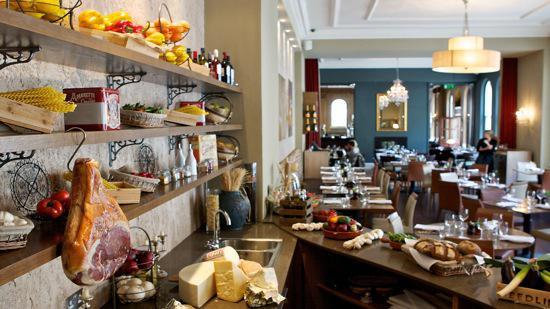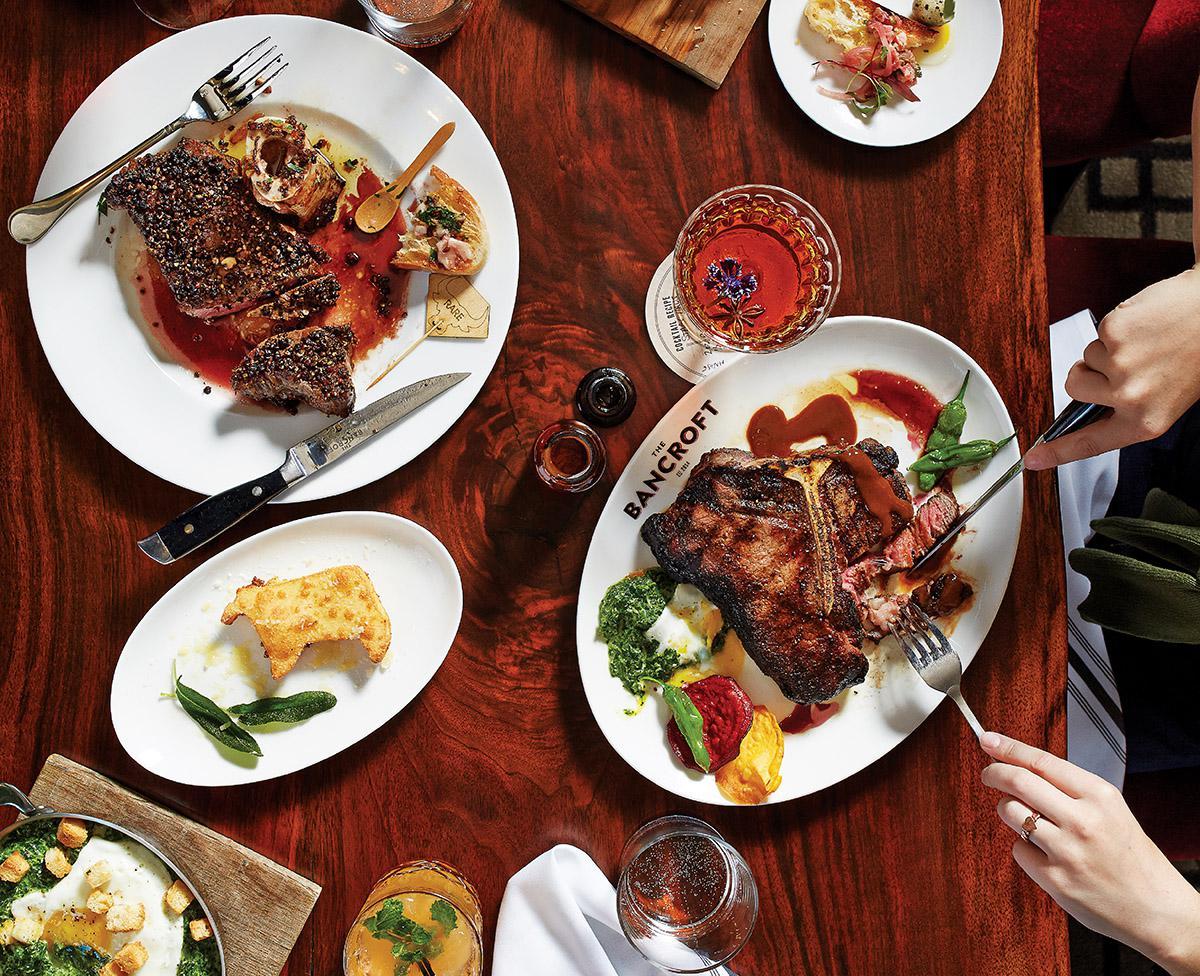The first image is the image on the left, the second image is the image on the right. For the images displayed, is the sentence "Hands are poised over a plate of food on a brown table holding multiple white plates in the right image." factually correct? Answer yes or no. Yes. 